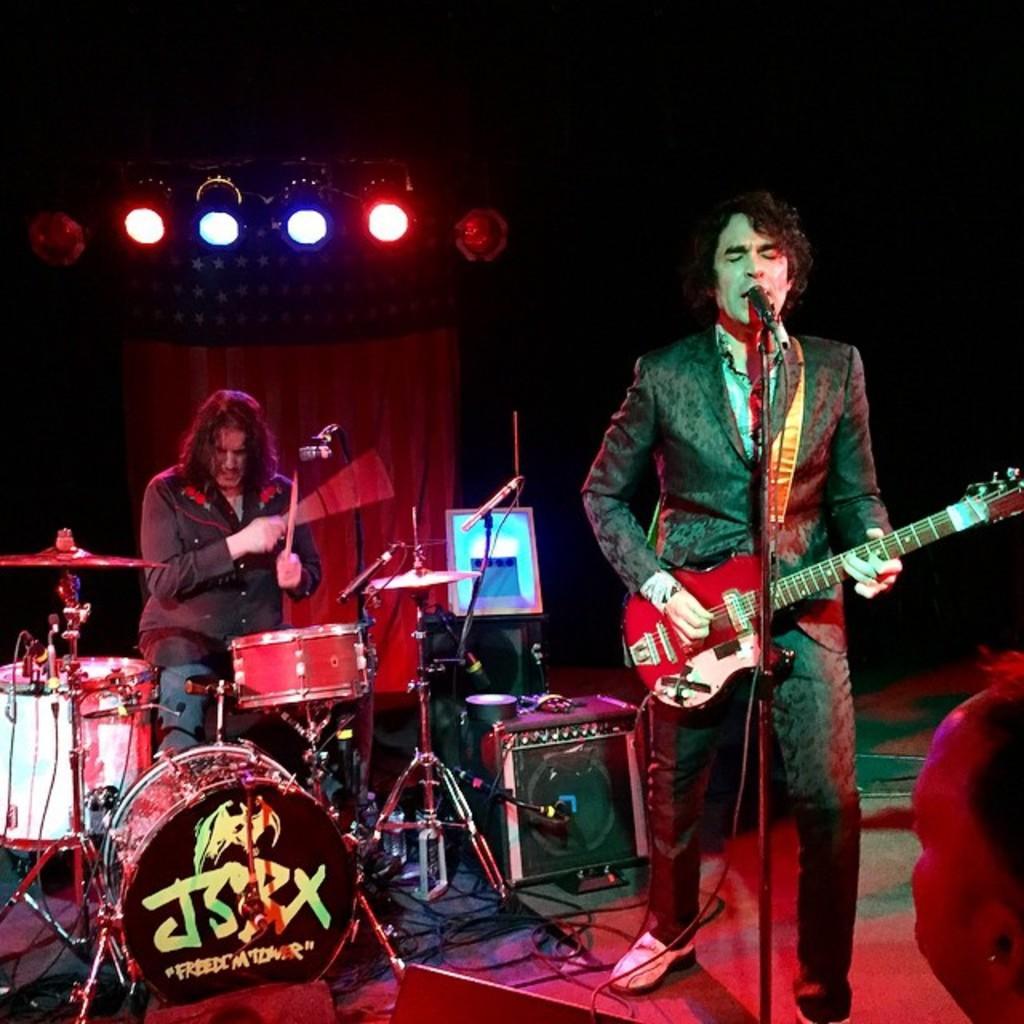Can you describe this image briefly? In this picture we can see a man holding a guitar and playing it in front of the mic and behind him there is an other man who is playing the drums and there are some lights. 